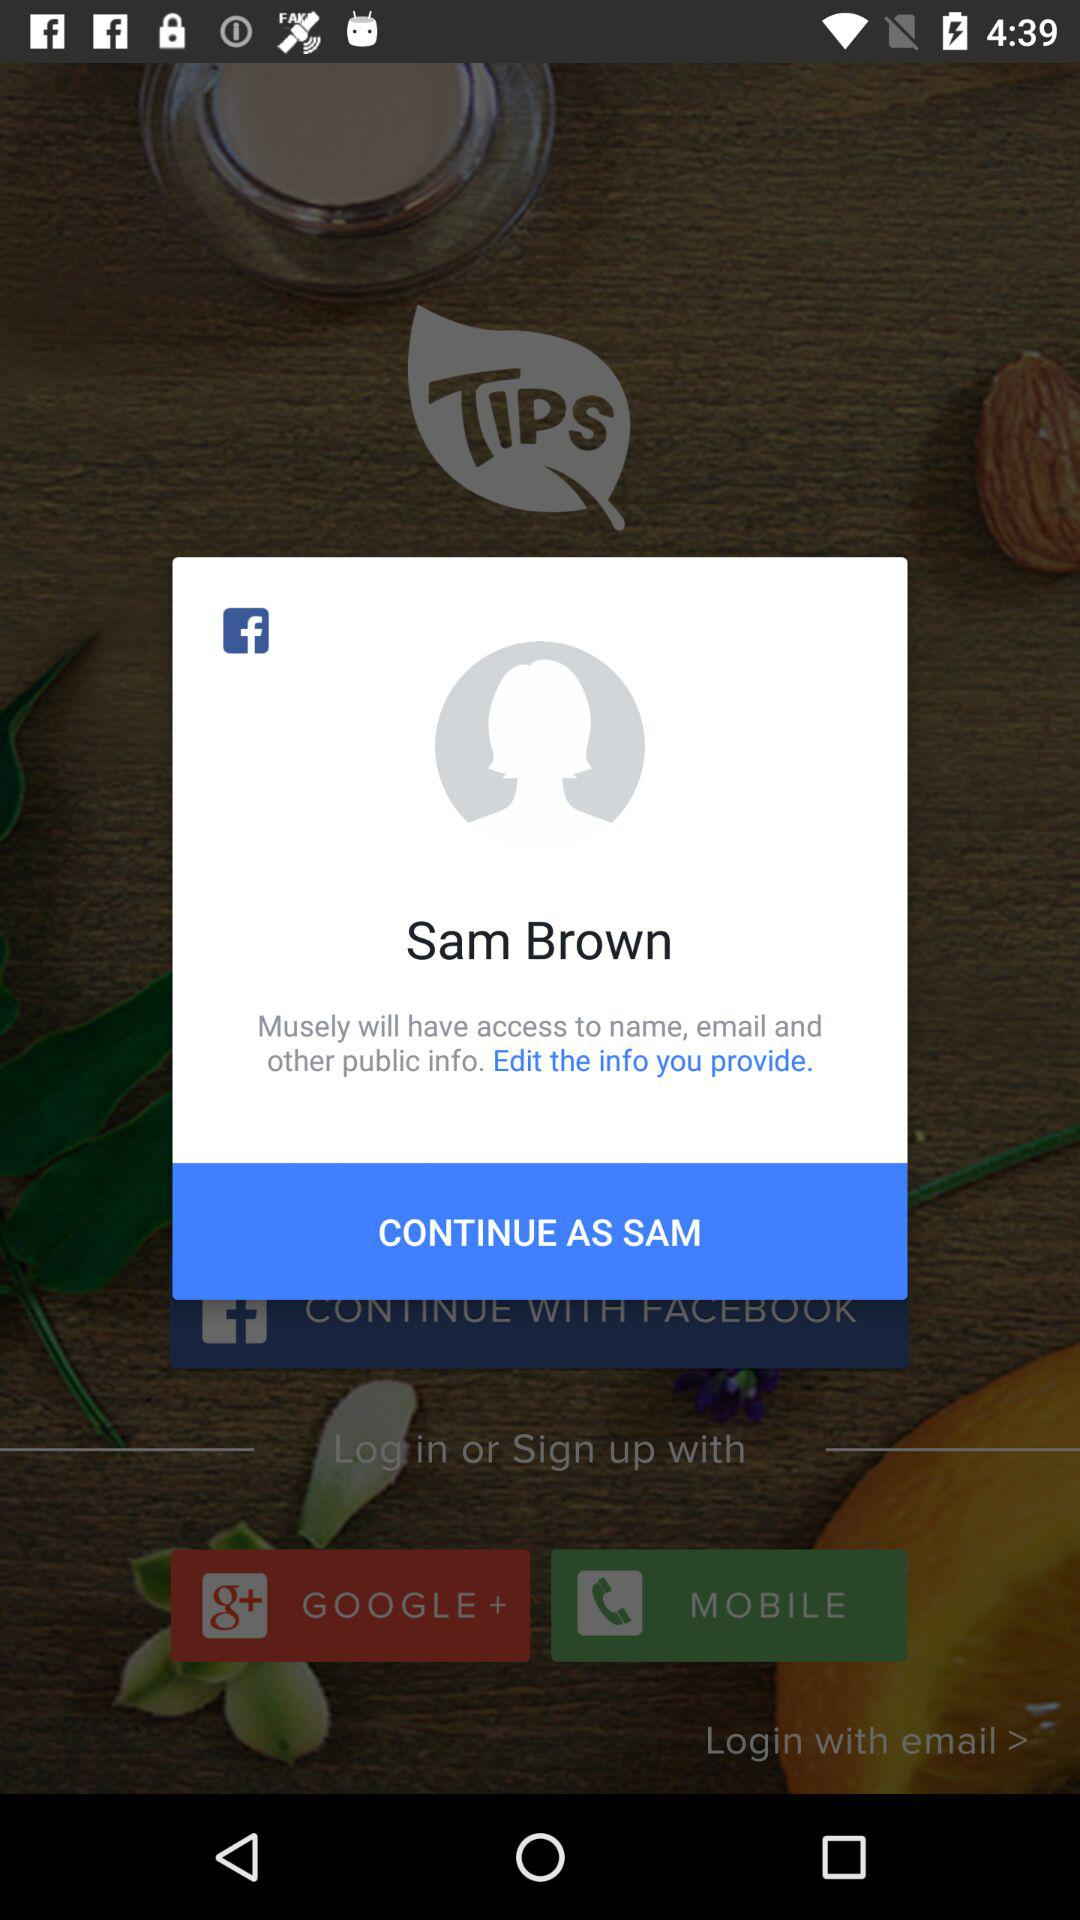What is the name of the user? The name of the user is Sam Brown. 